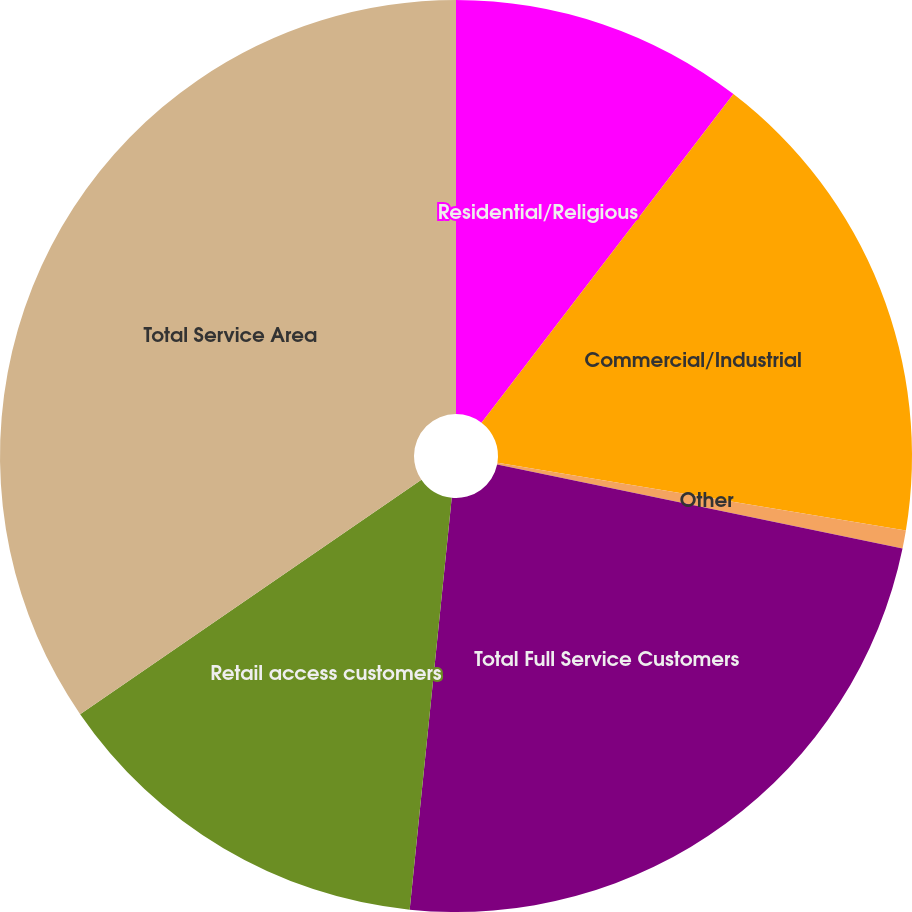Convert chart to OTSL. <chart><loc_0><loc_0><loc_500><loc_500><pie_chart><fcel>Residential/Religious<fcel>Commercial/Industrial<fcel>Other<fcel>Total Full Service Customers<fcel>Retail access customers<fcel>Total Service Area<nl><fcel>10.41%<fcel>17.2%<fcel>0.64%<fcel>23.37%<fcel>13.8%<fcel>34.58%<nl></chart> 